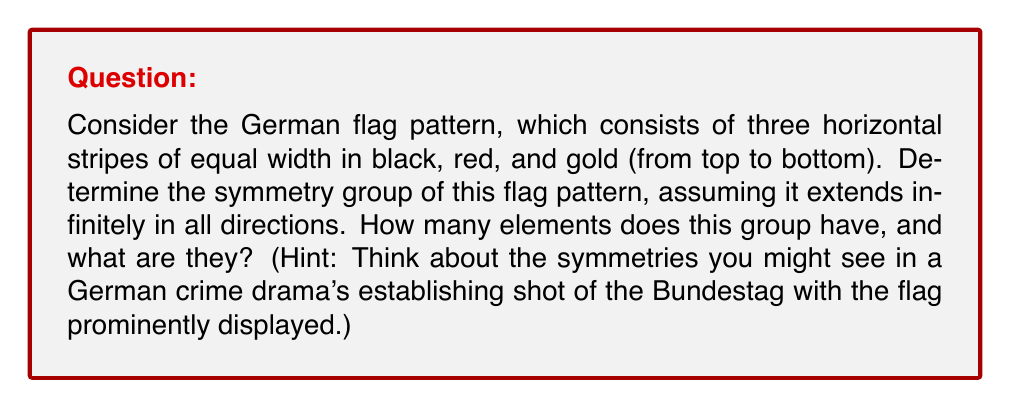Provide a solution to this math problem. Let's approach this step-by-step:

1) First, we need to consider what types of symmetries are possible for this pattern:

   a) Translations: The pattern repeats horizontally, so there are horizontal translations.
   b) Rotations: There are 180° rotations around points on the boundaries between stripes.
   c) Reflections: There are horizontal reflections along the boundaries between stripes.

2) Let's analyze each type of symmetry:

   a) Translations: There is a translation symmetry for any horizontal shift. We can represent this as $T_x$ where $x$ is any real number.

   b) Rotations: 180° rotations ($R_{180}$) around points on the boundaries between stripes. These are equivalent to a vertical reflection followed by a horizontal translation.

   c) Reflections: There are two types of reflections:
      - Horizontal reflections ($H_1$ and $H_2$) along the two boundaries between stripes.
      - Vertical reflections ($V_x$) at any point along the horizontal axis.

3) The symmetry group consists of all these transformations and their compositions. We can represent any element of this group as a composition of a horizontal translation, a vertical reflection (or identity), and a horizontal reflection (or identity).

4) Mathematically, we can express any element of the group as:

   $T_x \circ V_y \circ H_z$

   where $T_x$ is a horizontal translation by $x$, $V_y$ is either a vertical reflection at $y$ or the identity, and $H_z$ is either a horizontal reflection at $z$ or the identity.

5) This group is isomorphic to the direct product:

   $\mathbb{R} \times C_2 \times C_2$

   where $\mathbb{R}$ represents the translations, and each $C_2$ represents the choice of reflection or identity in the vertical and horizontal directions.

6) The number of elements in this group is uncountably infinite due to the continuous translation symmetry.
Answer: The symmetry group of the German flag pattern (extended infinitely) is isomorphic to $\mathbb{R} \times C_2 \times C_2$. This group has uncountably infinitely many elements, each of which can be represented as $T_x \circ V_y \circ H_z$, where $T_x$ is a horizontal translation, $V_y$ is either a vertical reflection or identity, and $H_z$ is either a horizontal reflection or identity. 